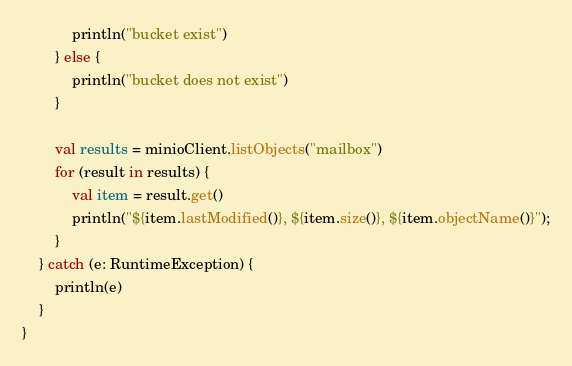Convert code to text. <code><loc_0><loc_0><loc_500><loc_500><_Kotlin_>            println("bucket exist")
        } else {
            println("bucket does not exist")
        }

        val results = minioClient.listObjects("mailbox")
        for (result in results) {
            val item = result.get()
            println("${item.lastModified()}, ${item.size()}, ${item.objectName()}");
        }
    } catch (e: RuntimeException) {
        println(e)
    }
}</code> 